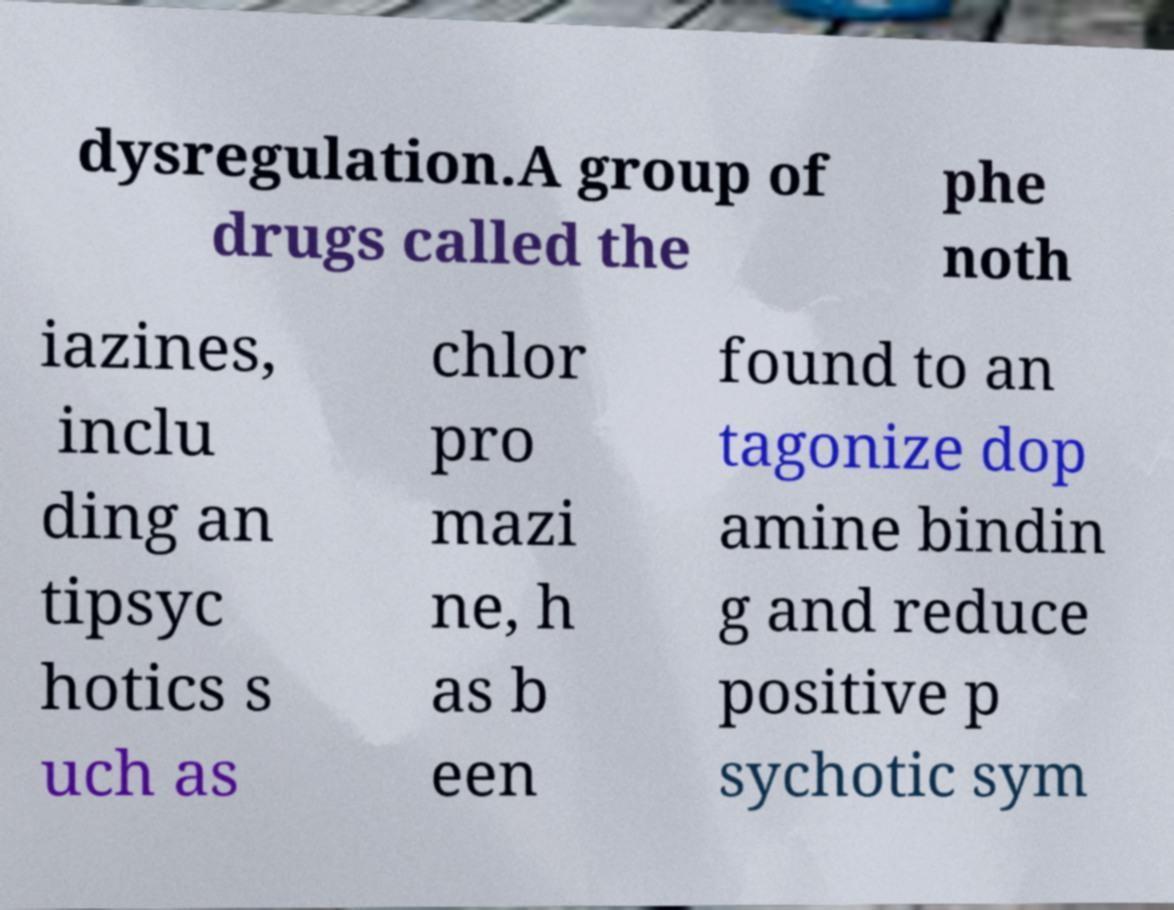Can you accurately transcribe the text from the provided image for me? dysregulation.A group of drugs called the phe noth iazines, inclu ding an tipsyc hotics s uch as chlor pro mazi ne, h as b een found to an tagonize dop amine bindin g and reduce positive p sychotic sym 